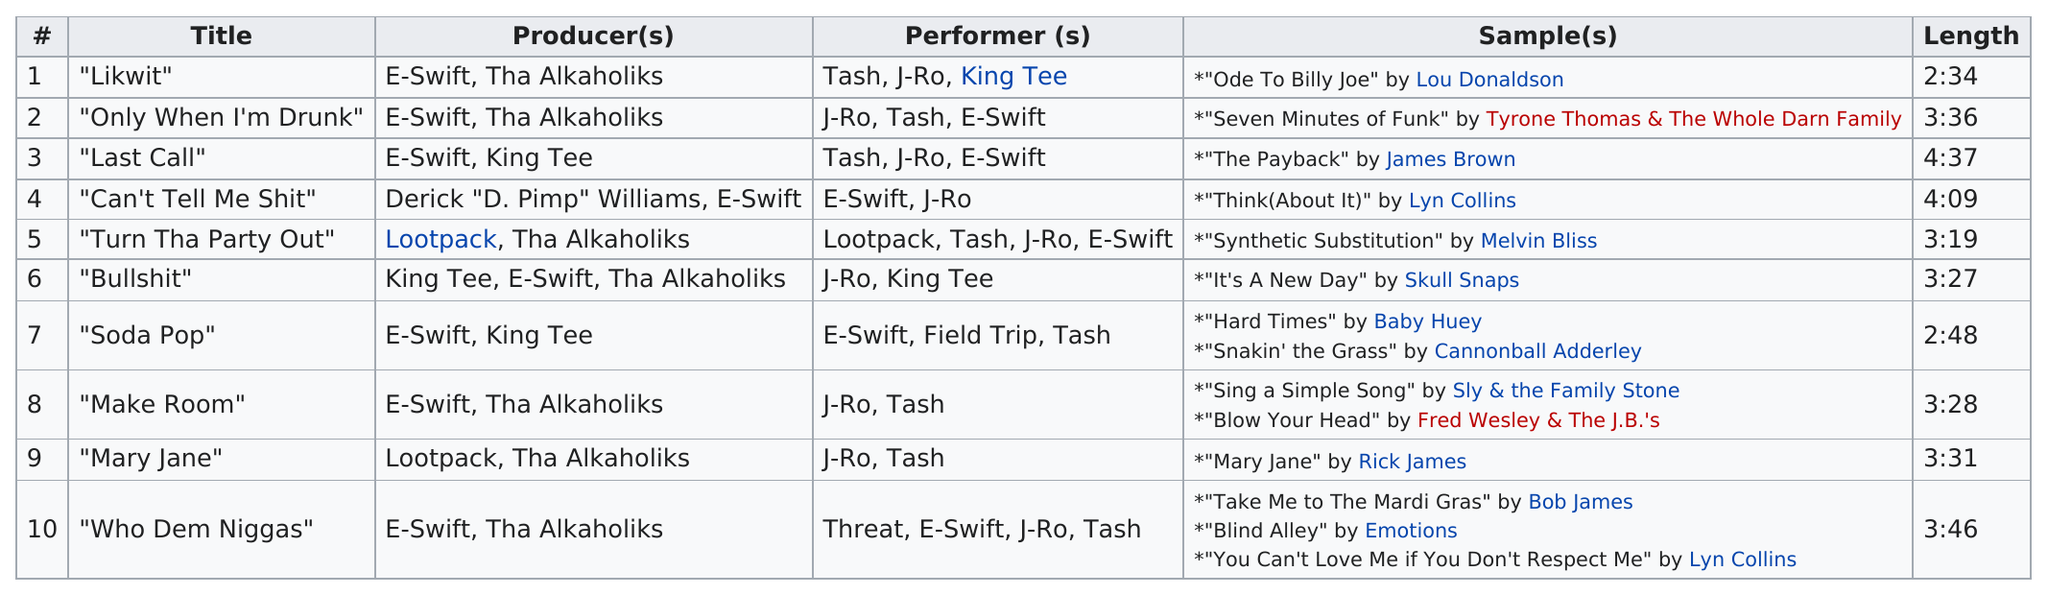Draw attention to some important aspects in this diagram. The duration of the song 'likwit' is 2 hours and 34 minutes. I declare that 'Only When I'm Drunk' is longer than 'Turn the Party Out.' The title listed before Mary Jane is 'Make Room.' J-Ro is listed as a performer nine times under the category of performers. E-swift produced a total of 8 songs. 